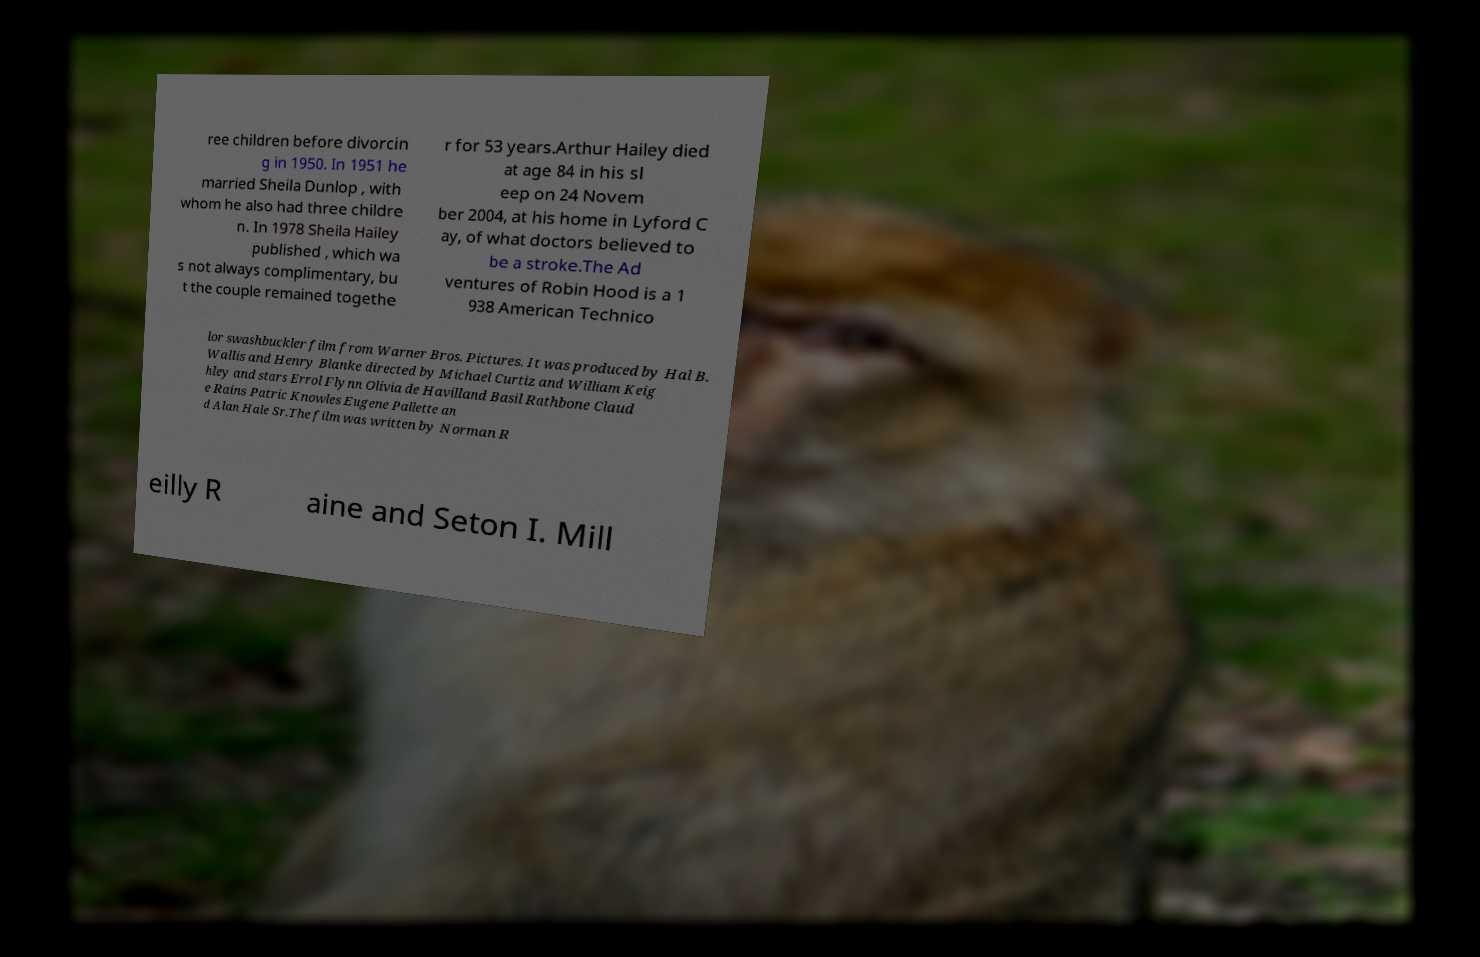Can you accurately transcribe the text from the provided image for me? ree children before divorcin g in 1950. In 1951 he married Sheila Dunlop , with whom he also had three childre n. In 1978 Sheila Hailey published , which wa s not always complimentary, bu t the couple remained togethe r for 53 years.Arthur Hailey died at age 84 in his sl eep on 24 Novem ber 2004, at his home in Lyford C ay, of what doctors believed to be a stroke.The Ad ventures of Robin Hood is a 1 938 American Technico lor swashbuckler film from Warner Bros. Pictures. It was produced by Hal B. Wallis and Henry Blanke directed by Michael Curtiz and William Keig hley and stars Errol Flynn Olivia de Havilland Basil Rathbone Claud e Rains Patric Knowles Eugene Pallette an d Alan Hale Sr.The film was written by Norman R eilly R aine and Seton I. Mill 